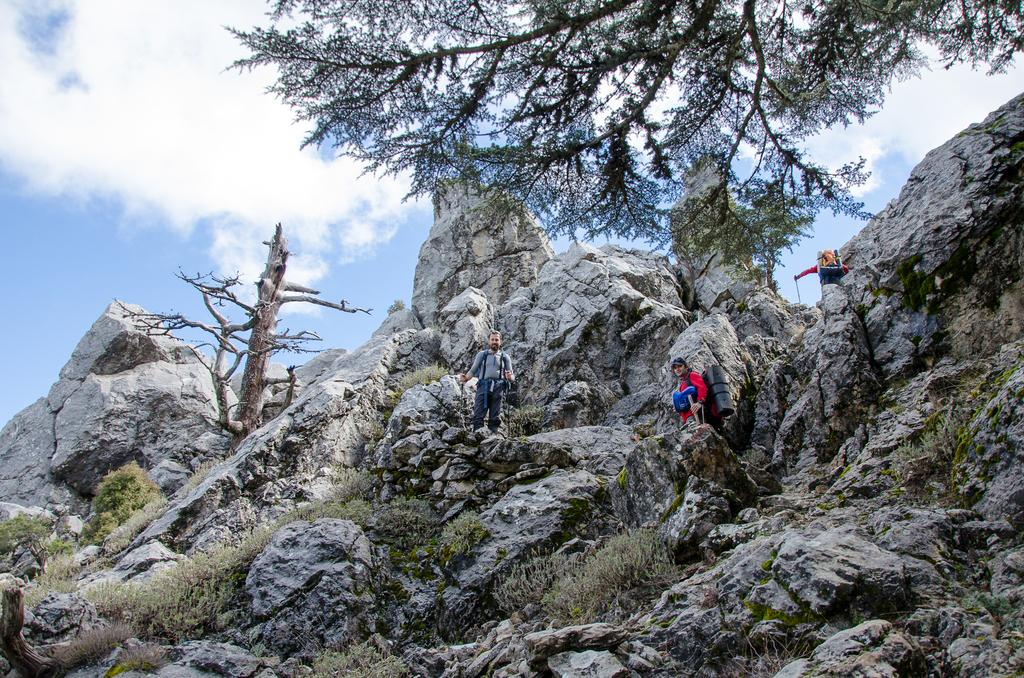What type of natural formation can be seen in the image? There are mountains in the image. Who or what else is present in the image? There are people in the image. What type of vegetation or plant life can be seen in the image? There is greenery in the image. What type of legal advice is the self-proclaimed lawyer providing in the image? There is no lawyer or legal advice present in the image; it features mountains, people, and greenery. What wish is being granted to the person in the image? There is no wish-granting or person with a wish present in the image. 